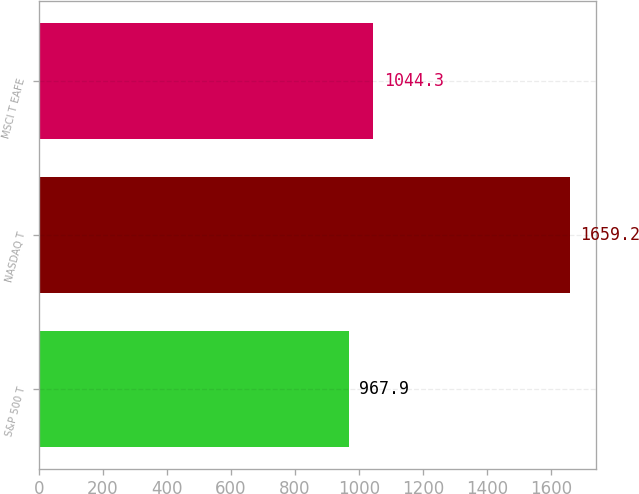Convert chart. <chart><loc_0><loc_0><loc_500><loc_500><bar_chart><fcel>S&P 500 T<fcel>NASDAQ T<fcel>MSCI T EAFE<nl><fcel>967.9<fcel>1659.2<fcel>1044.3<nl></chart> 